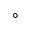<formula> <loc_0><loc_0><loc_500><loc_500>^ { \circ }</formula> 